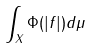<formula> <loc_0><loc_0><loc_500><loc_500>\int _ { X } \Phi ( | f | ) d \mu</formula> 